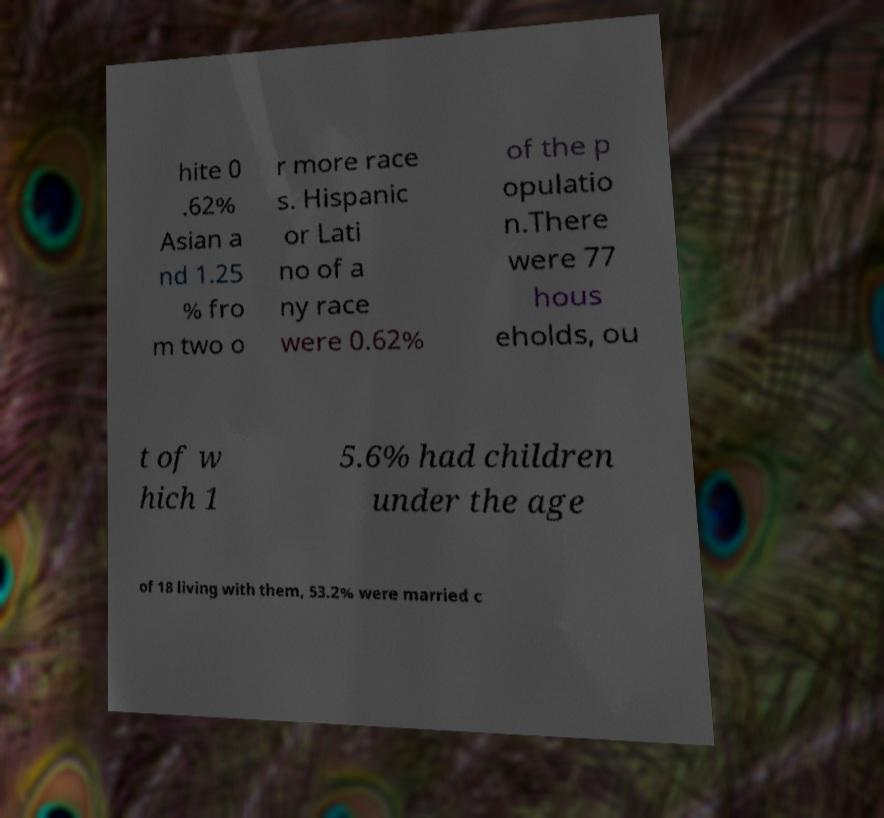Please read and relay the text visible in this image. What does it say? hite 0 .62% Asian a nd 1.25 % fro m two o r more race s. Hispanic or Lati no of a ny race were 0.62% of the p opulatio n.There were 77 hous eholds, ou t of w hich 1 5.6% had children under the age of 18 living with them, 53.2% were married c 